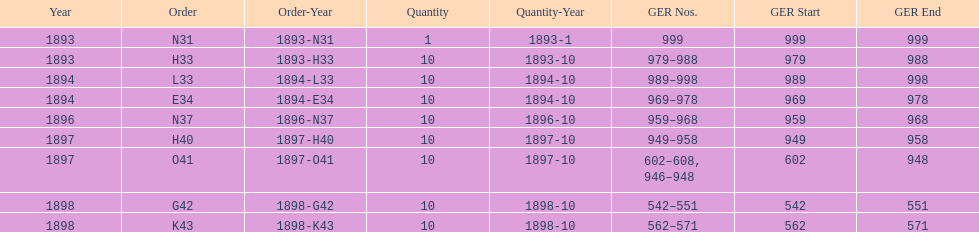What is the duration of years with a quantity of 10? 5. 